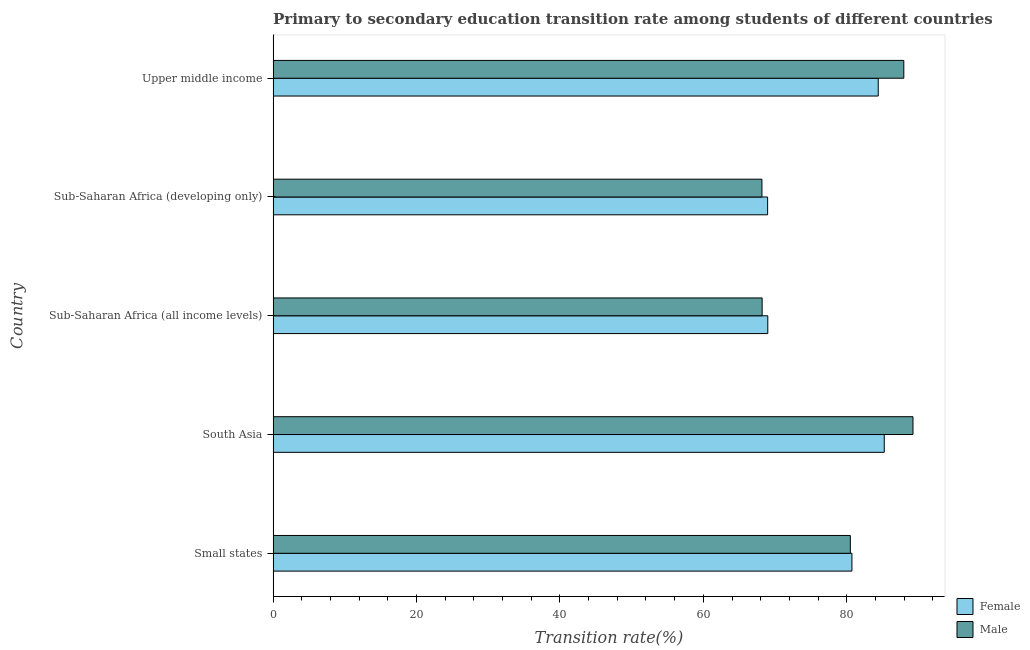How many different coloured bars are there?
Provide a succinct answer. 2. How many bars are there on the 5th tick from the top?
Ensure brevity in your answer.  2. How many bars are there on the 2nd tick from the bottom?
Give a very brief answer. 2. What is the label of the 3rd group of bars from the top?
Offer a very short reply. Sub-Saharan Africa (all income levels). What is the transition rate among male students in Sub-Saharan Africa (developing only)?
Your answer should be compact. 68.17. Across all countries, what is the maximum transition rate among female students?
Offer a terse response. 85.23. Across all countries, what is the minimum transition rate among female students?
Keep it short and to the point. 68.96. In which country was the transition rate among male students minimum?
Your response must be concise. Sub-Saharan Africa (developing only). What is the total transition rate among female students in the graph?
Your answer should be compact. 388.29. What is the difference between the transition rate among male students in South Asia and that in Upper middle income?
Give a very brief answer. 1.28. What is the difference between the transition rate among male students in South Asia and the transition rate among female students in Upper middle income?
Your answer should be very brief. 4.85. What is the average transition rate among male students per country?
Offer a very short reply. 78.81. What is the difference between the transition rate among female students and transition rate among male students in Sub-Saharan Africa (developing only)?
Keep it short and to the point. 0.79. What is the ratio of the transition rate among male students in Sub-Saharan Africa (developing only) to that in Upper middle income?
Offer a very short reply. 0.78. Is the difference between the transition rate among male students in Sub-Saharan Africa (all income levels) and Upper middle income greater than the difference between the transition rate among female students in Sub-Saharan Africa (all income levels) and Upper middle income?
Ensure brevity in your answer.  No. What is the difference between the highest and the second highest transition rate among female students?
Keep it short and to the point. 0.84. What is the difference between the highest and the lowest transition rate among male students?
Make the answer very short. 21.07. Are all the bars in the graph horizontal?
Ensure brevity in your answer.  Yes. Are the values on the major ticks of X-axis written in scientific E-notation?
Give a very brief answer. No. Does the graph contain any zero values?
Provide a succinct answer. No. Does the graph contain grids?
Keep it short and to the point. No. Where does the legend appear in the graph?
Provide a short and direct response. Bottom right. How are the legend labels stacked?
Offer a terse response. Vertical. What is the title of the graph?
Keep it short and to the point. Primary to secondary education transition rate among students of different countries. What is the label or title of the X-axis?
Make the answer very short. Transition rate(%). What is the Transition rate(%) in Female in Small states?
Offer a terse response. 80.72. What is the Transition rate(%) of Male in Small states?
Make the answer very short. 80.5. What is the Transition rate(%) of Female in South Asia?
Your answer should be very brief. 85.23. What is the Transition rate(%) in Male in South Asia?
Your answer should be compact. 89.24. What is the Transition rate(%) of Female in Sub-Saharan Africa (all income levels)?
Your response must be concise. 68.99. What is the Transition rate(%) in Male in Sub-Saharan Africa (all income levels)?
Offer a very short reply. 68.2. What is the Transition rate(%) in Female in Sub-Saharan Africa (developing only)?
Offer a terse response. 68.96. What is the Transition rate(%) of Male in Sub-Saharan Africa (developing only)?
Provide a short and direct response. 68.17. What is the Transition rate(%) in Female in Upper middle income?
Your answer should be compact. 84.39. What is the Transition rate(%) of Male in Upper middle income?
Your answer should be compact. 87.96. Across all countries, what is the maximum Transition rate(%) in Female?
Provide a succinct answer. 85.23. Across all countries, what is the maximum Transition rate(%) of Male?
Provide a short and direct response. 89.24. Across all countries, what is the minimum Transition rate(%) of Female?
Give a very brief answer. 68.96. Across all countries, what is the minimum Transition rate(%) in Male?
Your response must be concise. 68.17. What is the total Transition rate(%) in Female in the graph?
Your answer should be very brief. 388.29. What is the total Transition rate(%) in Male in the graph?
Provide a succinct answer. 394.06. What is the difference between the Transition rate(%) of Female in Small states and that in South Asia?
Ensure brevity in your answer.  -4.51. What is the difference between the Transition rate(%) in Male in Small states and that in South Asia?
Keep it short and to the point. -8.74. What is the difference between the Transition rate(%) of Female in Small states and that in Sub-Saharan Africa (all income levels)?
Keep it short and to the point. 11.73. What is the difference between the Transition rate(%) of Male in Small states and that in Sub-Saharan Africa (all income levels)?
Provide a short and direct response. 12.3. What is the difference between the Transition rate(%) of Female in Small states and that in Sub-Saharan Africa (developing only)?
Offer a very short reply. 11.76. What is the difference between the Transition rate(%) in Male in Small states and that in Sub-Saharan Africa (developing only)?
Make the answer very short. 12.33. What is the difference between the Transition rate(%) in Female in Small states and that in Upper middle income?
Your answer should be compact. -3.67. What is the difference between the Transition rate(%) in Male in Small states and that in Upper middle income?
Your response must be concise. -7.46. What is the difference between the Transition rate(%) in Female in South Asia and that in Sub-Saharan Africa (all income levels)?
Keep it short and to the point. 16.24. What is the difference between the Transition rate(%) of Male in South Asia and that in Sub-Saharan Africa (all income levels)?
Your answer should be very brief. 21.04. What is the difference between the Transition rate(%) in Female in South Asia and that in Sub-Saharan Africa (developing only)?
Keep it short and to the point. 16.27. What is the difference between the Transition rate(%) in Male in South Asia and that in Sub-Saharan Africa (developing only)?
Make the answer very short. 21.07. What is the difference between the Transition rate(%) of Female in South Asia and that in Upper middle income?
Make the answer very short. 0.84. What is the difference between the Transition rate(%) in Male in South Asia and that in Upper middle income?
Your response must be concise. 1.28. What is the difference between the Transition rate(%) in Female in Sub-Saharan Africa (all income levels) and that in Sub-Saharan Africa (developing only)?
Offer a terse response. 0.03. What is the difference between the Transition rate(%) of Male in Sub-Saharan Africa (all income levels) and that in Sub-Saharan Africa (developing only)?
Provide a short and direct response. 0.03. What is the difference between the Transition rate(%) of Female in Sub-Saharan Africa (all income levels) and that in Upper middle income?
Offer a terse response. -15.4. What is the difference between the Transition rate(%) of Male in Sub-Saharan Africa (all income levels) and that in Upper middle income?
Your answer should be very brief. -19.76. What is the difference between the Transition rate(%) in Female in Sub-Saharan Africa (developing only) and that in Upper middle income?
Offer a very short reply. -15.43. What is the difference between the Transition rate(%) in Male in Sub-Saharan Africa (developing only) and that in Upper middle income?
Ensure brevity in your answer.  -19.79. What is the difference between the Transition rate(%) of Female in Small states and the Transition rate(%) of Male in South Asia?
Provide a succinct answer. -8.52. What is the difference between the Transition rate(%) of Female in Small states and the Transition rate(%) of Male in Sub-Saharan Africa (all income levels)?
Provide a short and direct response. 12.52. What is the difference between the Transition rate(%) of Female in Small states and the Transition rate(%) of Male in Sub-Saharan Africa (developing only)?
Your answer should be compact. 12.55. What is the difference between the Transition rate(%) in Female in Small states and the Transition rate(%) in Male in Upper middle income?
Make the answer very short. -7.24. What is the difference between the Transition rate(%) of Female in South Asia and the Transition rate(%) of Male in Sub-Saharan Africa (all income levels)?
Your answer should be very brief. 17.03. What is the difference between the Transition rate(%) in Female in South Asia and the Transition rate(%) in Male in Sub-Saharan Africa (developing only)?
Your answer should be compact. 17.06. What is the difference between the Transition rate(%) of Female in South Asia and the Transition rate(%) of Male in Upper middle income?
Offer a very short reply. -2.73. What is the difference between the Transition rate(%) in Female in Sub-Saharan Africa (all income levels) and the Transition rate(%) in Male in Sub-Saharan Africa (developing only)?
Your answer should be compact. 0.82. What is the difference between the Transition rate(%) of Female in Sub-Saharan Africa (all income levels) and the Transition rate(%) of Male in Upper middle income?
Provide a succinct answer. -18.97. What is the difference between the Transition rate(%) in Female in Sub-Saharan Africa (developing only) and the Transition rate(%) in Male in Upper middle income?
Offer a terse response. -19. What is the average Transition rate(%) in Female per country?
Your answer should be compact. 77.66. What is the average Transition rate(%) in Male per country?
Your answer should be very brief. 78.81. What is the difference between the Transition rate(%) of Female and Transition rate(%) of Male in Small states?
Keep it short and to the point. 0.22. What is the difference between the Transition rate(%) in Female and Transition rate(%) in Male in South Asia?
Your answer should be compact. -4.01. What is the difference between the Transition rate(%) of Female and Transition rate(%) of Male in Sub-Saharan Africa (all income levels)?
Ensure brevity in your answer.  0.79. What is the difference between the Transition rate(%) in Female and Transition rate(%) in Male in Sub-Saharan Africa (developing only)?
Provide a short and direct response. 0.79. What is the difference between the Transition rate(%) of Female and Transition rate(%) of Male in Upper middle income?
Your response must be concise. -3.57. What is the ratio of the Transition rate(%) of Female in Small states to that in South Asia?
Your response must be concise. 0.95. What is the ratio of the Transition rate(%) in Male in Small states to that in South Asia?
Provide a succinct answer. 0.9. What is the ratio of the Transition rate(%) in Female in Small states to that in Sub-Saharan Africa (all income levels)?
Provide a short and direct response. 1.17. What is the ratio of the Transition rate(%) in Male in Small states to that in Sub-Saharan Africa (all income levels)?
Your answer should be compact. 1.18. What is the ratio of the Transition rate(%) of Female in Small states to that in Sub-Saharan Africa (developing only)?
Ensure brevity in your answer.  1.17. What is the ratio of the Transition rate(%) in Male in Small states to that in Sub-Saharan Africa (developing only)?
Provide a short and direct response. 1.18. What is the ratio of the Transition rate(%) of Female in Small states to that in Upper middle income?
Make the answer very short. 0.96. What is the ratio of the Transition rate(%) of Male in Small states to that in Upper middle income?
Provide a succinct answer. 0.92. What is the ratio of the Transition rate(%) in Female in South Asia to that in Sub-Saharan Africa (all income levels)?
Your answer should be very brief. 1.24. What is the ratio of the Transition rate(%) of Male in South Asia to that in Sub-Saharan Africa (all income levels)?
Provide a succinct answer. 1.31. What is the ratio of the Transition rate(%) in Female in South Asia to that in Sub-Saharan Africa (developing only)?
Provide a short and direct response. 1.24. What is the ratio of the Transition rate(%) of Male in South Asia to that in Sub-Saharan Africa (developing only)?
Provide a short and direct response. 1.31. What is the ratio of the Transition rate(%) in Female in South Asia to that in Upper middle income?
Give a very brief answer. 1.01. What is the ratio of the Transition rate(%) of Male in South Asia to that in Upper middle income?
Provide a short and direct response. 1.01. What is the ratio of the Transition rate(%) in Female in Sub-Saharan Africa (all income levels) to that in Sub-Saharan Africa (developing only)?
Offer a terse response. 1. What is the ratio of the Transition rate(%) of Male in Sub-Saharan Africa (all income levels) to that in Sub-Saharan Africa (developing only)?
Provide a succinct answer. 1. What is the ratio of the Transition rate(%) in Female in Sub-Saharan Africa (all income levels) to that in Upper middle income?
Provide a short and direct response. 0.82. What is the ratio of the Transition rate(%) in Male in Sub-Saharan Africa (all income levels) to that in Upper middle income?
Keep it short and to the point. 0.78. What is the ratio of the Transition rate(%) of Female in Sub-Saharan Africa (developing only) to that in Upper middle income?
Give a very brief answer. 0.82. What is the ratio of the Transition rate(%) of Male in Sub-Saharan Africa (developing only) to that in Upper middle income?
Provide a succinct answer. 0.78. What is the difference between the highest and the second highest Transition rate(%) of Female?
Your answer should be compact. 0.84. What is the difference between the highest and the second highest Transition rate(%) in Male?
Offer a very short reply. 1.28. What is the difference between the highest and the lowest Transition rate(%) in Female?
Your response must be concise. 16.27. What is the difference between the highest and the lowest Transition rate(%) of Male?
Ensure brevity in your answer.  21.07. 